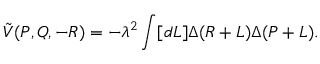<formula> <loc_0><loc_0><loc_500><loc_500>\tilde { V } ( P , Q , - R ) = - \lambda ^ { 2 } \int [ d L ] \Delta ( R + L ) \Delta ( P + L ) .</formula> 